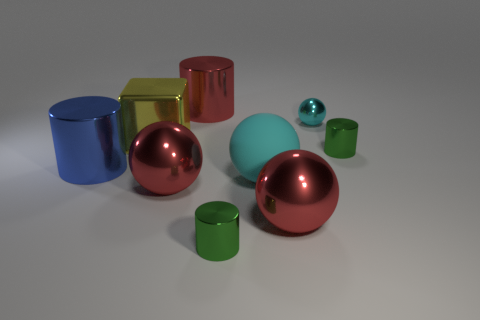Subtract all large blue cylinders. How many cylinders are left? 3 Add 1 green metal things. How many objects exist? 10 Subtract all cylinders. How many objects are left? 5 Subtract 1 cubes. How many cubes are left? 0 Subtract all cyan balls. How many balls are left? 2 Add 7 tiny spheres. How many tiny spheres are left? 8 Add 7 cyan metal objects. How many cyan metal objects exist? 8 Subtract 2 red balls. How many objects are left? 7 Subtract all purple blocks. Subtract all purple cylinders. How many blocks are left? 1 Subtract all brown balls. How many brown cubes are left? 0 